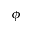<formula> <loc_0><loc_0><loc_500><loc_500>\phi</formula> 